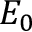<formula> <loc_0><loc_0><loc_500><loc_500>E _ { 0 }</formula> 